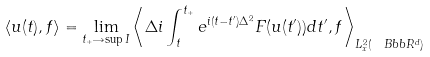Convert formula to latex. <formula><loc_0><loc_0><loc_500><loc_500>\langle u ( t ) , f \rangle = \lim _ { t _ { + } \rightarrow \sup { I } } \left \langle \Delta i \int _ { t } ^ { t _ { + } } e ^ { i ( t - t ^ { \prime } ) \Delta ^ { 2 } } F ( u ( t ^ { \prime } ) ) d t ^ { \prime } , f \right \rangle _ { L _ { x } ^ { 2 } ( \ B b b R ^ { d } ) }</formula> 